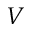Convert formula to latex. <formula><loc_0><loc_0><loc_500><loc_500>V</formula> 